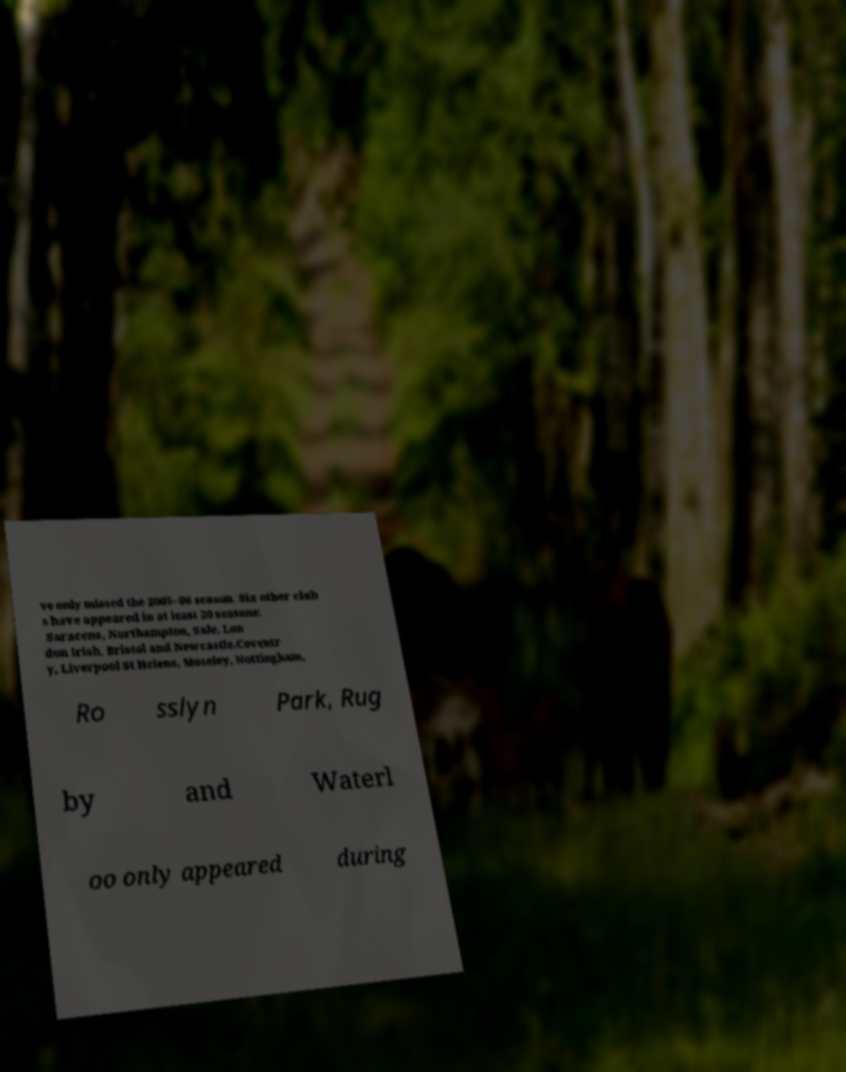I need the written content from this picture converted into text. Can you do that? ve only missed the 2005–06 season. Six other club s have appeared in at least 20 seasons: Saracens, Northampton, Sale, Lon don Irish, Bristol and Newcastle.Coventr y, Liverpool St Helens, Moseley, Nottingham, Ro sslyn Park, Rug by and Waterl oo only appeared during 